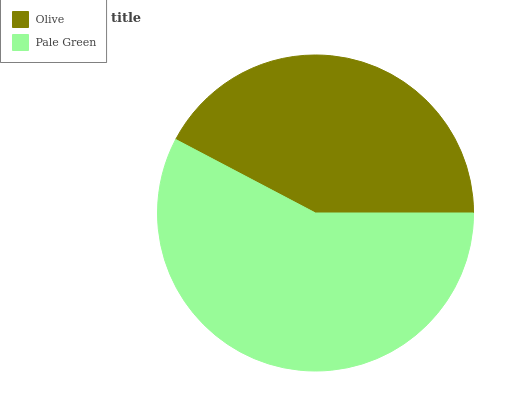Is Olive the minimum?
Answer yes or no. Yes. Is Pale Green the maximum?
Answer yes or no. Yes. Is Pale Green the minimum?
Answer yes or no. No. Is Pale Green greater than Olive?
Answer yes or no. Yes. Is Olive less than Pale Green?
Answer yes or no. Yes. Is Olive greater than Pale Green?
Answer yes or no. No. Is Pale Green less than Olive?
Answer yes or no. No. Is Pale Green the high median?
Answer yes or no. Yes. Is Olive the low median?
Answer yes or no. Yes. Is Olive the high median?
Answer yes or no. No. Is Pale Green the low median?
Answer yes or no. No. 